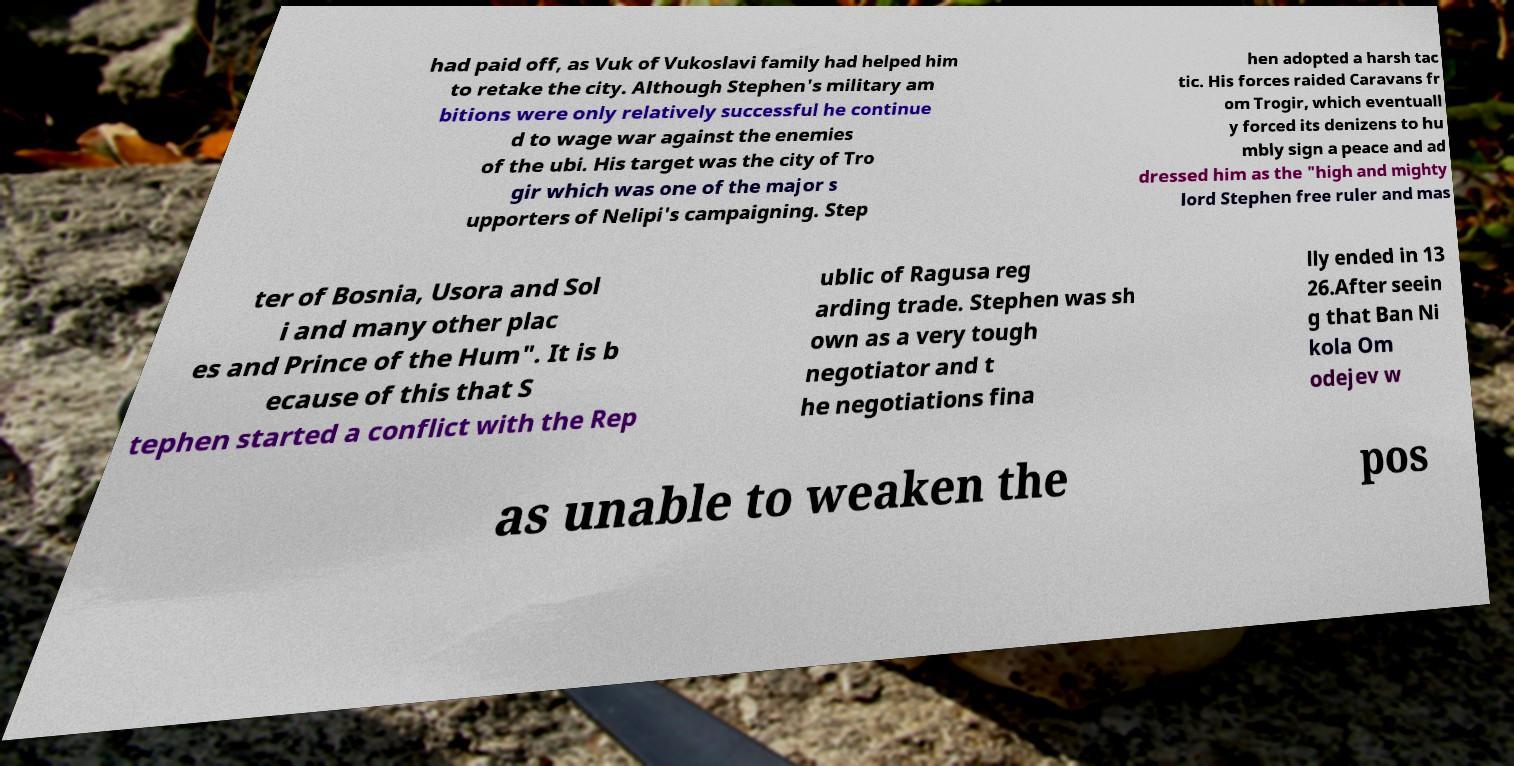Please read and relay the text visible in this image. What does it say? had paid off, as Vuk of Vukoslavi family had helped him to retake the city. Although Stephen's military am bitions were only relatively successful he continue d to wage war against the enemies of the ubi. His target was the city of Tro gir which was one of the major s upporters of Nelipi's campaigning. Step hen adopted a harsh tac tic. His forces raided Caravans fr om Trogir, which eventuall y forced its denizens to hu mbly sign a peace and ad dressed him as the "high and mighty lord Stephen free ruler and mas ter of Bosnia, Usora and Sol i and many other plac es and Prince of the Hum". It is b ecause of this that S tephen started a conflict with the Rep ublic of Ragusa reg arding trade. Stephen was sh own as a very tough negotiator and t he negotiations fina lly ended in 13 26.After seein g that Ban Ni kola Om odejev w as unable to weaken the pos 